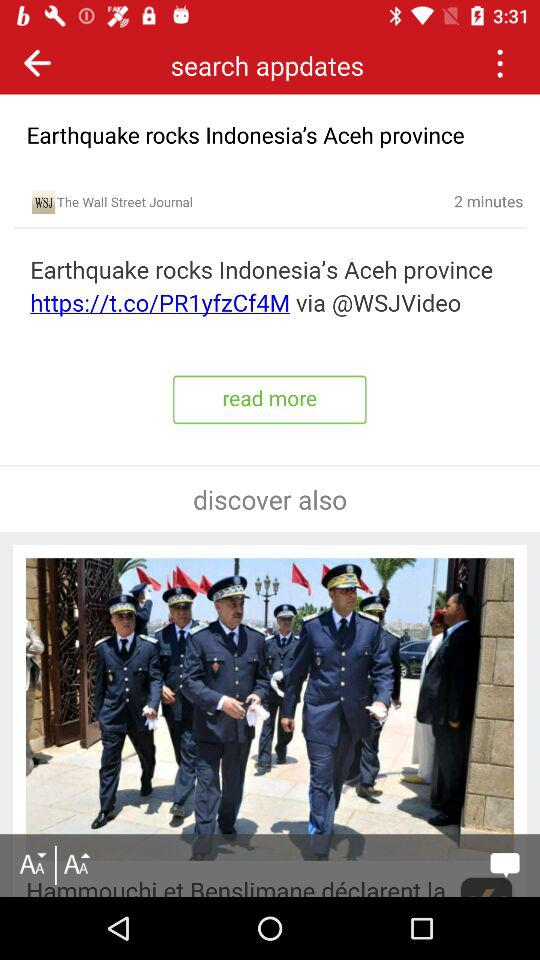By whom was the post posted? The post was posted by "The Wall Street Journal". 